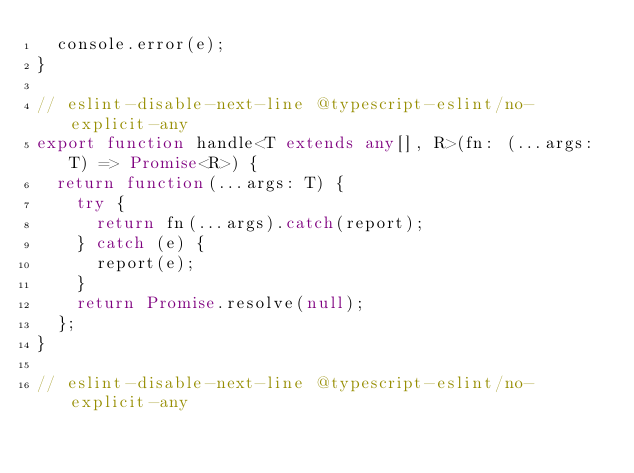Convert code to text. <code><loc_0><loc_0><loc_500><loc_500><_TypeScript_>  console.error(e);
}

// eslint-disable-next-line @typescript-eslint/no-explicit-any
export function handle<T extends any[], R>(fn: (...args: T) => Promise<R>) {
  return function(...args: T) {
    try {
      return fn(...args).catch(report);
    } catch (e) {
      report(e);
    }
    return Promise.resolve(null);
  };
}

// eslint-disable-next-line @typescript-eslint/no-explicit-any</code> 